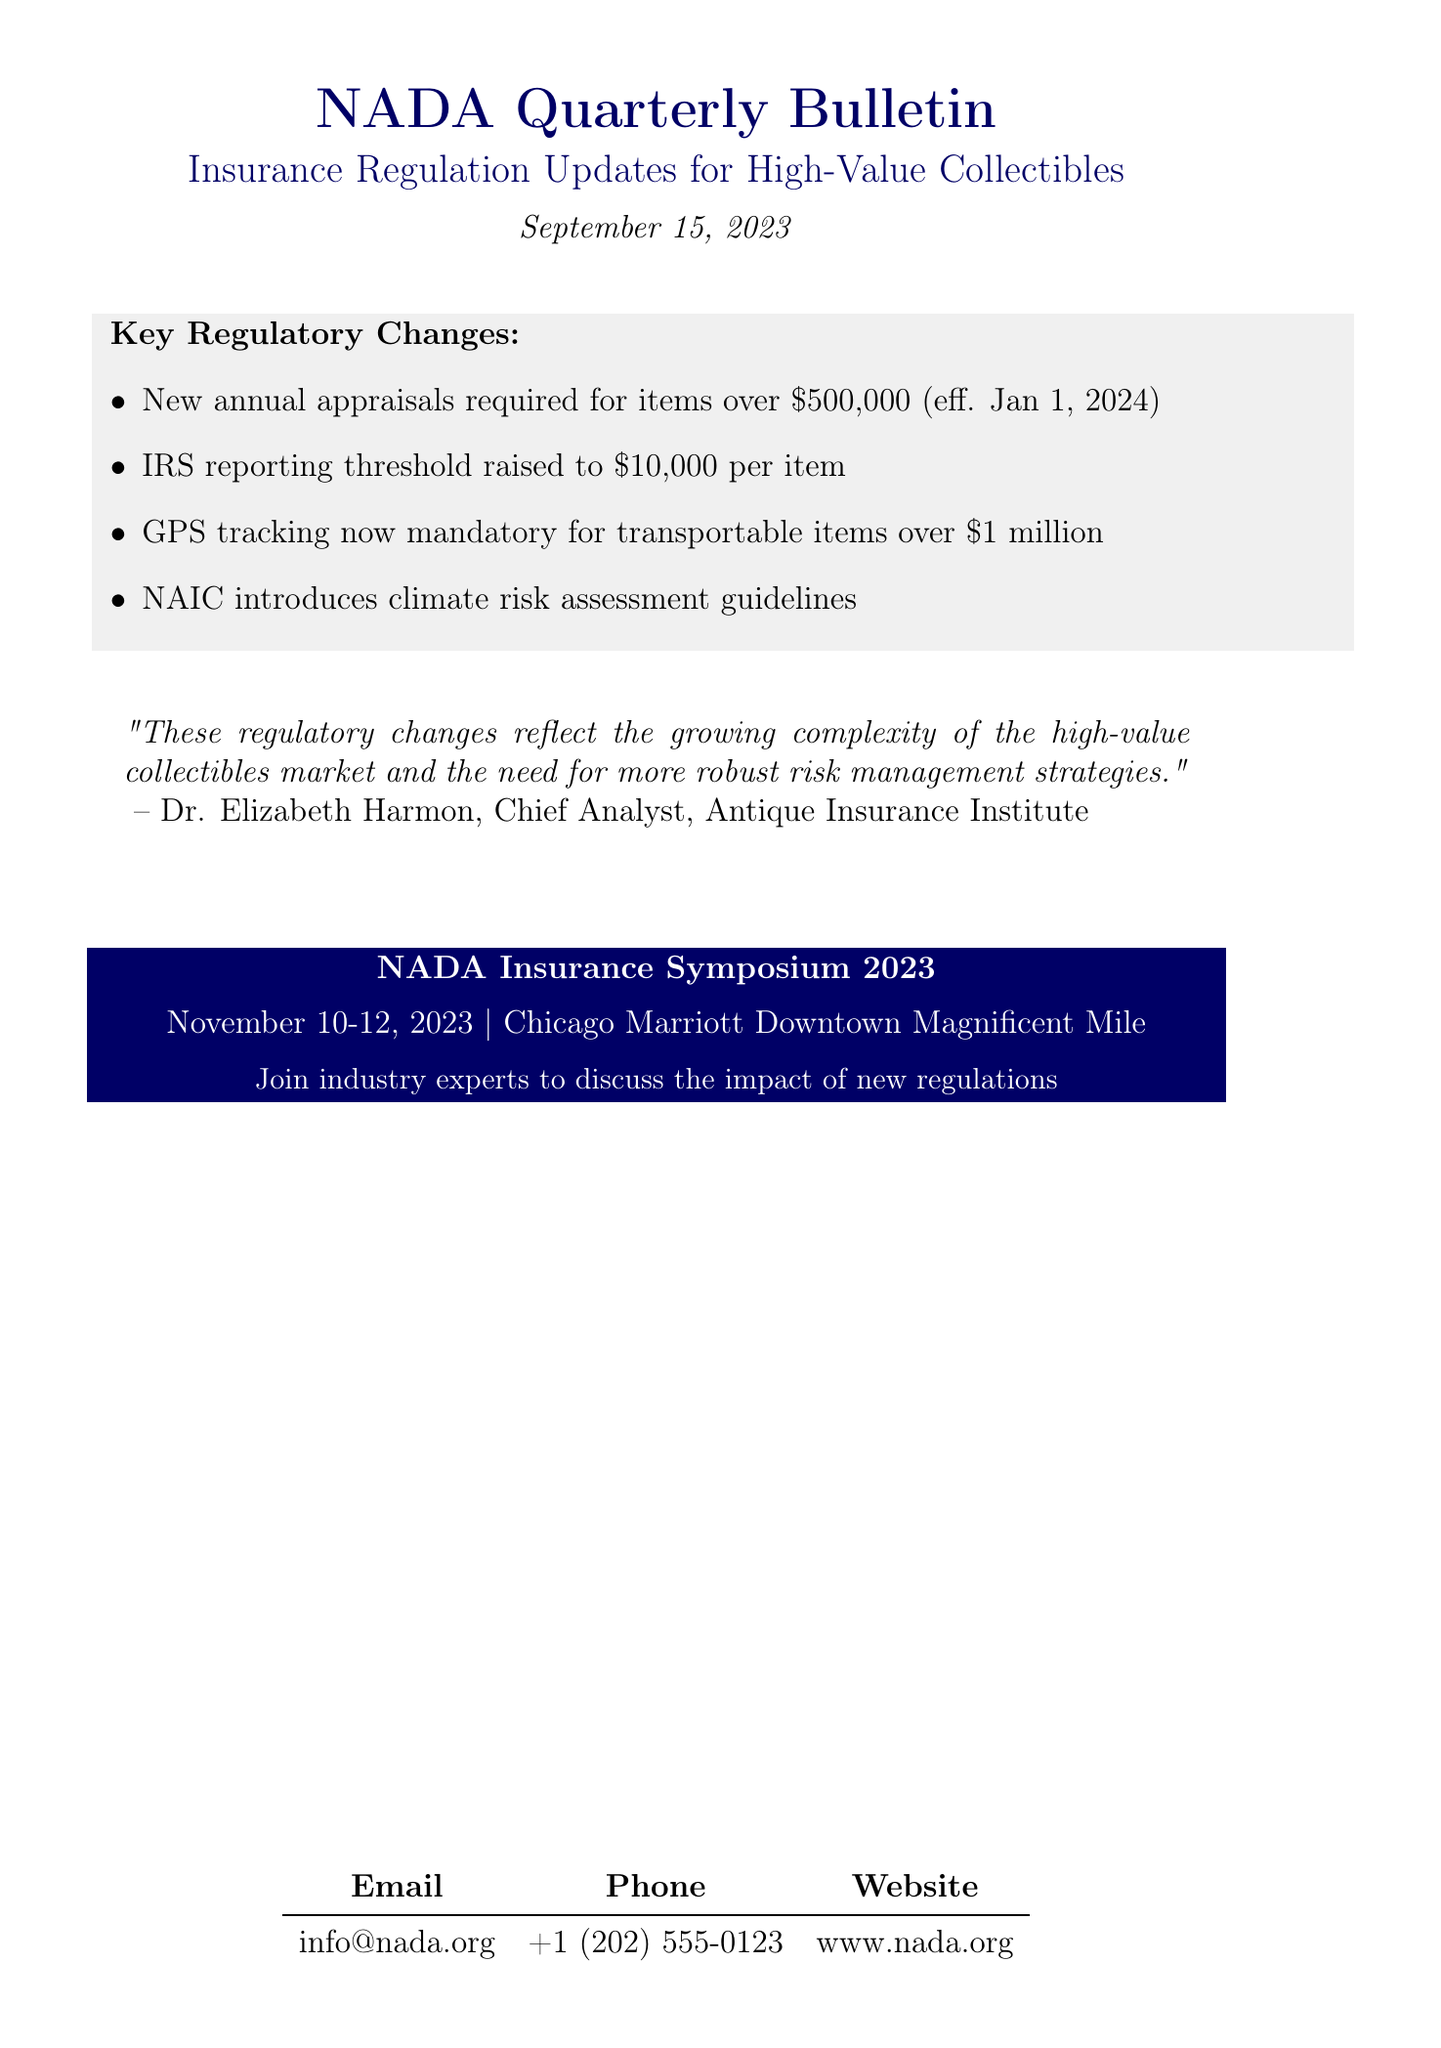What is the title of the newsletter? The title of the newsletter is the main heading found at the beginning of the document.
Answer: NADA Quarterly Bulletin: Insurance Regulation Updates for High-Value Collectibles When was the newsletter published? The publication date is stated clearly beneath the title of the document.
Answer: September 15, 2023 What is the new appraisal requirement for high-value collectibles? The details regarding appraisals are found under the key regulatory changes section of the document.
Answer: Annual appraisals for items valued over $500,000 What is the new IRS reporting threshold for insured collectibles? This information is specified in the key points of the newsletter.
Answer: $10,000 per item What geographic location will host the NADA Insurance Symposium 2023? The location is clearly noted in the upcoming event section of the document.
Answer: Chicago Marriott Downtown Magnificent Mile What is the effective date for the new appraisal requirements? The effective date is indicated alongside the appraisal requirements in the key points.
Answer: January 1, 2024 Who is the Chief Analyst at the Antique Insurance Institute? The expert opinion section identifies the individual along with their title.
Answer: Dr. Elizabeth Harmon What type of devices are now required for transportable items valued over $1 million? This is mentioned in the key regulatory changes regarding enhanced security measures.
Answer: GPS tracking devices What event is scheduled for November 10-12, 2023? The upcoming event section outlines this particular event's name and dates.
Answer: NADA Insurance Symposium 2023 